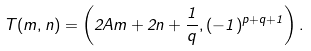<formula> <loc_0><loc_0><loc_500><loc_500>T ( m , n ) = \left ( 2 A m + 2 n + \frac { 1 } { q } , ( - 1 ) ^ { p + q + 1 } \right ) .</formula> 